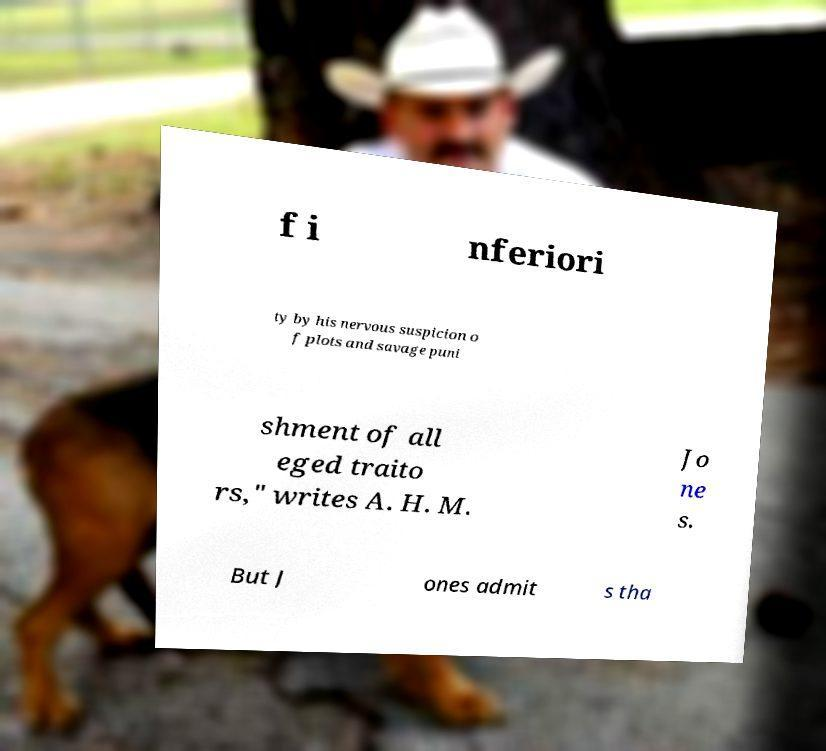Could you extract and type out the text from this image? f i nferiori ty by his nervous suspicion o f plots and savage puni shment of all eged traito rs," writes A. H. M. Jo ne s. But J ones admit s tha 